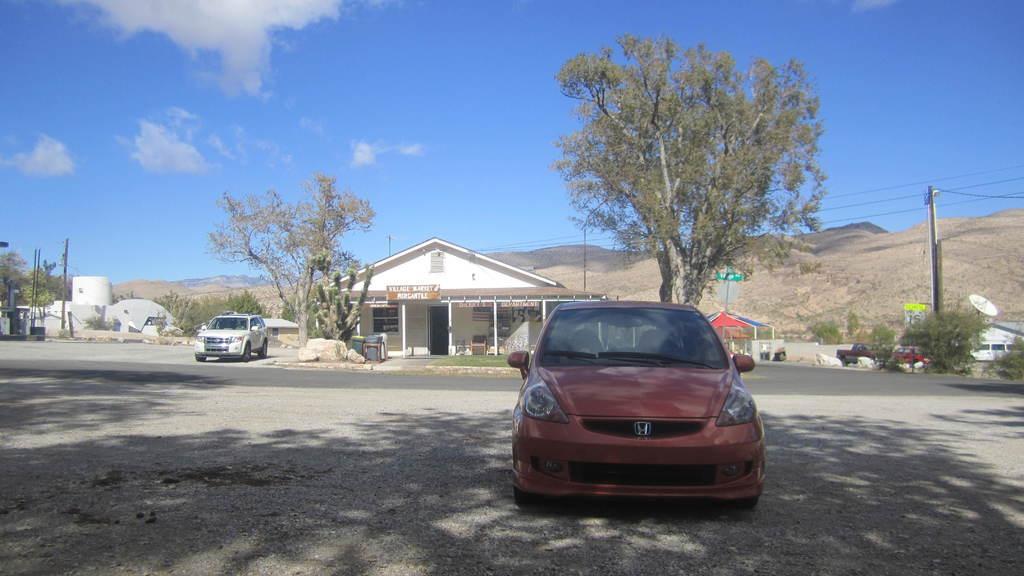In one or two sentences, can you explain what this image depicts? In this picture I can see a car in the middle, in the background there are trees and a house, on the left side a vehicle is moving on the road, at the top there is the sky. 